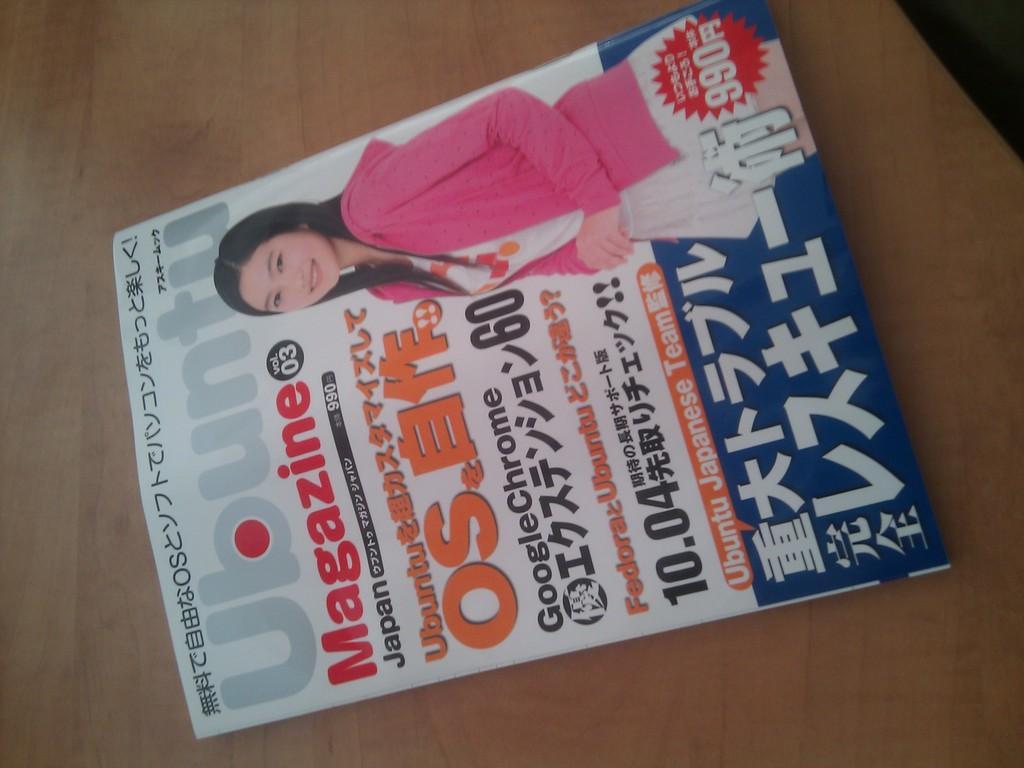Can you describe this image briefly? This is the paper, on this there is an image of a woman. She wore pink color dress. 